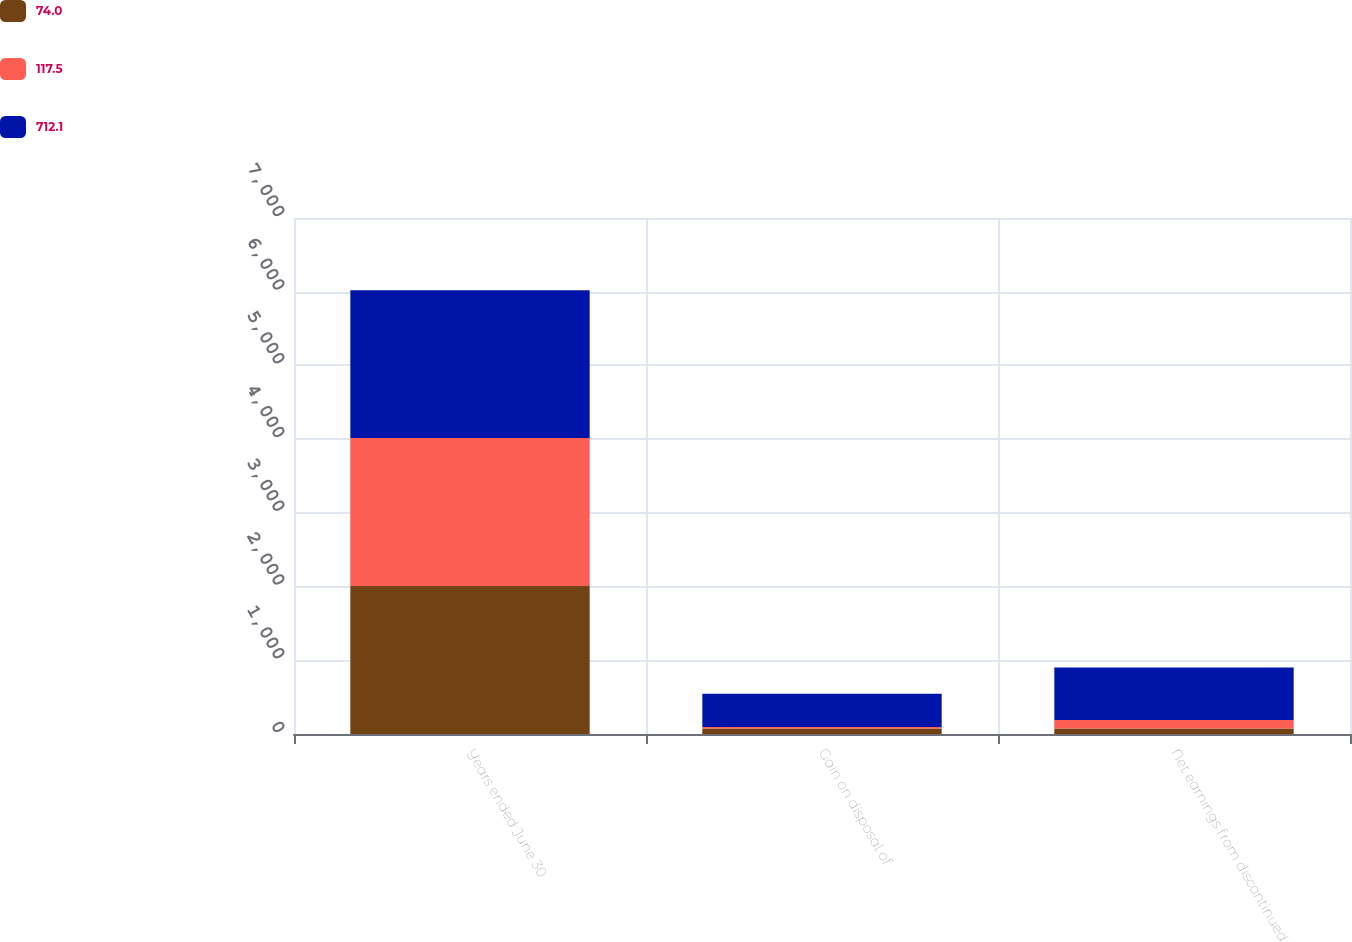<chart> <loc_0><loc_0><loc_500><loc_500><stacked_bar_chart><ecel><fcel>Years ended June 30<fcel>Gain on disposal of<fcel>Net earnings from discontinued<nl><fcel>74<fcel>2008<fcel>74<fcel>74<nl><fcel>117.5<fcel>2007<fcel>20.9<fcel>117.5<nl><fcel>712.1<fcel>2006<fcel>452.8<fcel>712.1<nl></chart> 